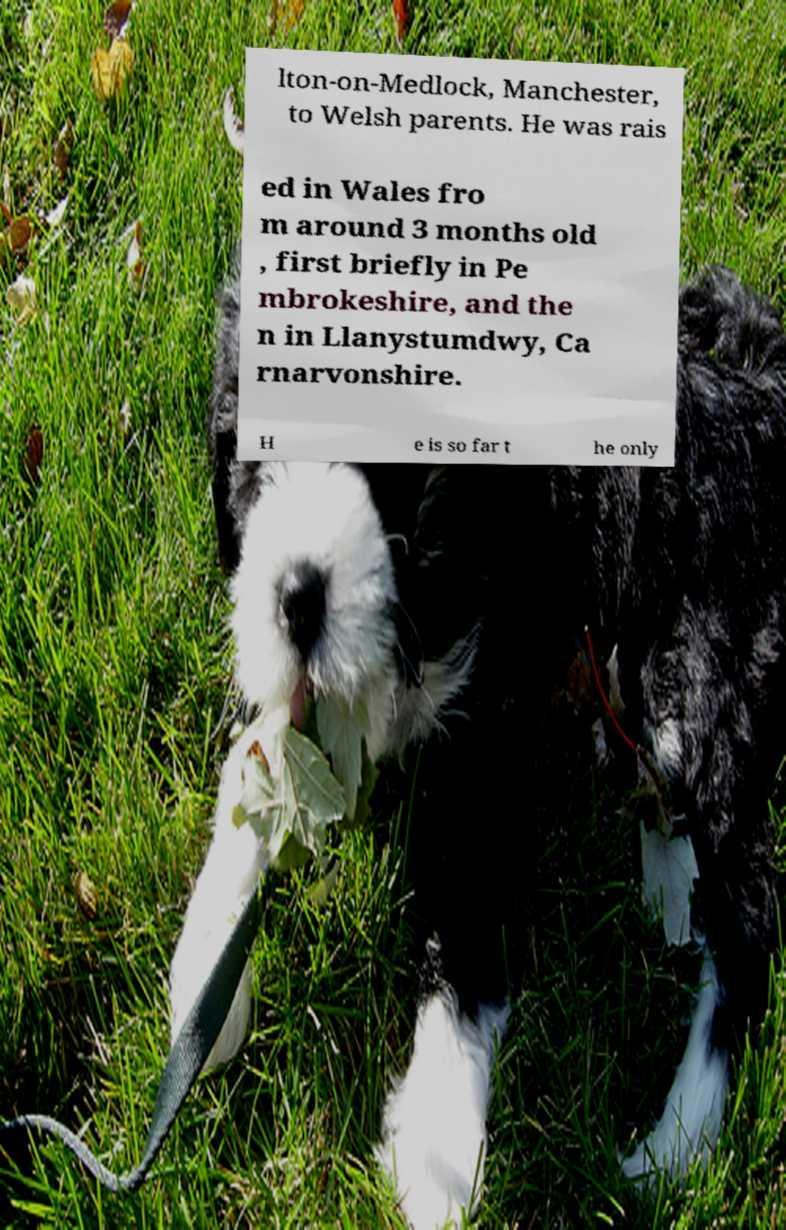Please identify and transcribe the text found in this image. lton-on-Medlock, Manchester, to Welsh parents. He was rais ed in Wales fro m around 3 months old , first briefly in Pe mbrokeshire, and the n in Llanystumdwy, Ca rnarvonshire. H e is so far t he only 